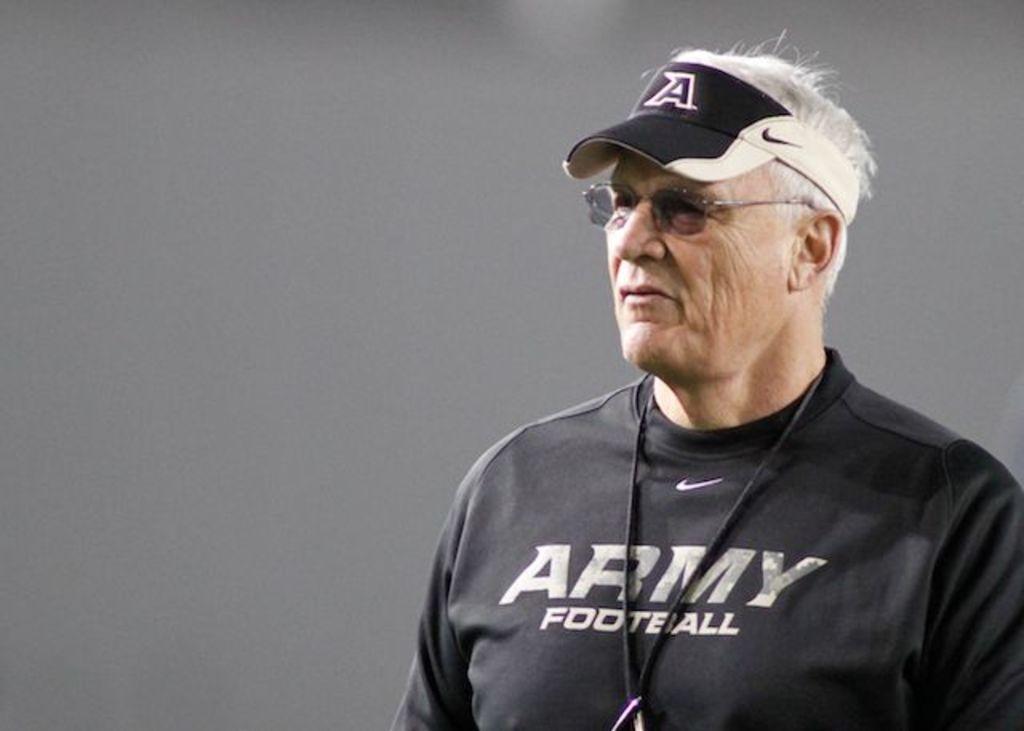What team does he coach for?
Offer a terse response. Army. What sport does this person like?
Give a very brief answer. Football. 